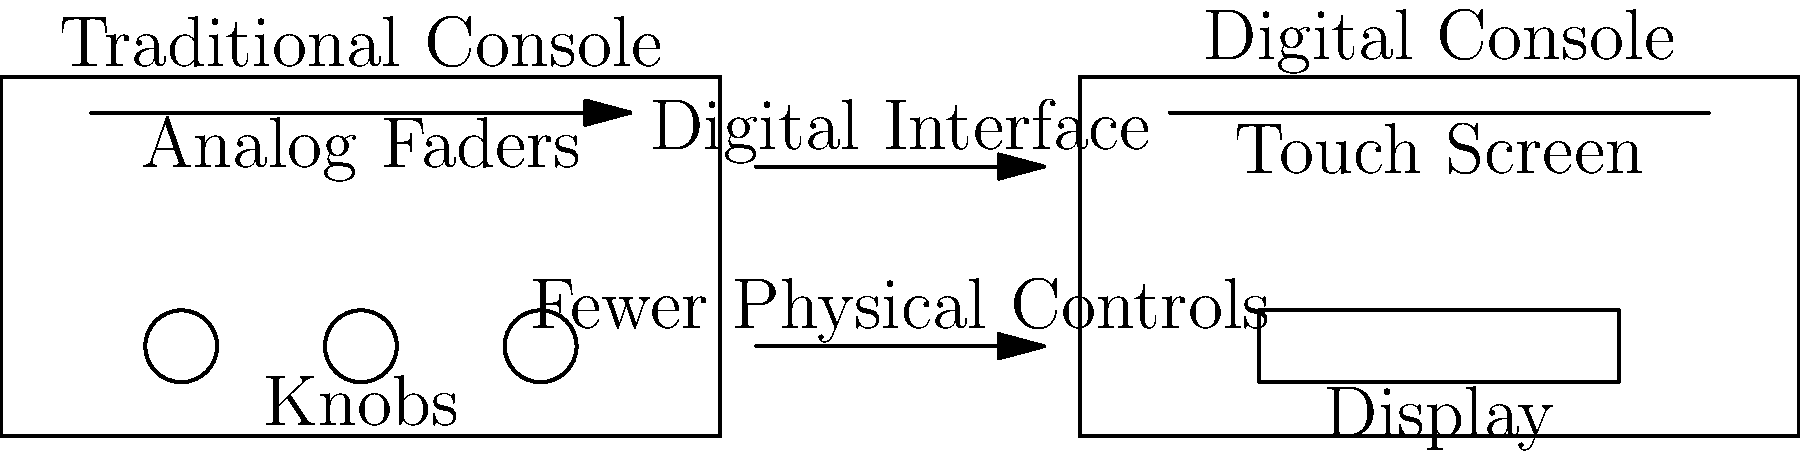As a DJ familiar with both traditional and digital mixing consoles, what is the most significant functional difference between the two types of consoles shown in the image? To answer this question, let's analyze the key differences between the traditional and digital mixing consoles shown in the image:

1. Interface:
   - Traditional Console: Features physical analog faders and multiple knobs.
   - Digital Console: Has a touch screen interface and a display.

2. Controls:
   - Traditional Console: Numerous physical controls (faders and knobs).
   - Digital Console: Fewer physical controls, relying more on digital interface.

3. Functionality:
   - Traditional Console: Direct, tactile control over audio parameters.
   - Digital Console: Software-based control, allowing for more complex operations and presets.

4. Flexibility:
   - Traditional Console: Fixed layout and functionality.
   - Digital Console: Customizable interface and expandable features through software updates.

5. Signal Processing:
   - Traditional Console: Analog signal path.
   - Digital Console: Digital signal processing, allowing for more advanced effects and routing options.

The most significant functional difference is the shift from analog to digital signal processing. This change enables more complex operations, greater flexibility, and the ability to save and recall settings, which is crucial for modern DJs and producers like DBN Gogo.
Answer: Digital signal processing 